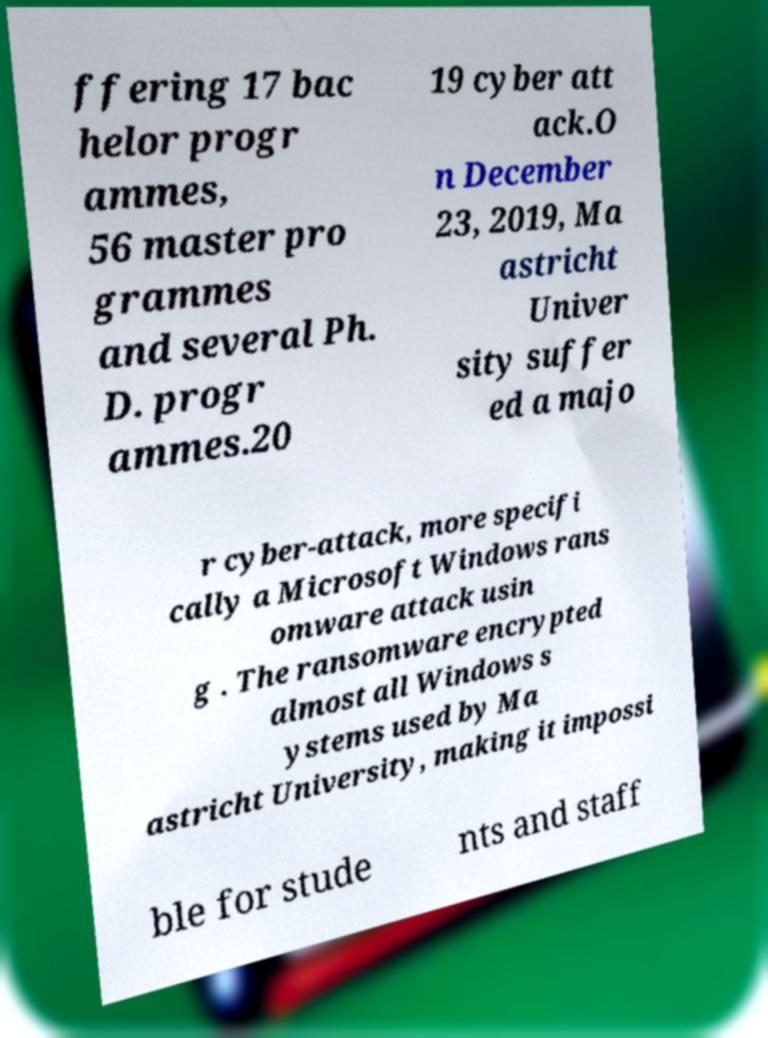Please read and relay the text visible in this image. What does it say? ffering 17 bac helor progr ammes, 56 master pro grammes and several Ph. D. progr ammes.20 19 cyber att ack.O n December 23, 2019, Ma astricht Univer sity suffer ed a majo r cyber-attack, more specifi cally a Microsoft Windows rans omware attack usin g . The ransomware encrypted almost all Windows s ystems used by Ma astricht University, making it impossi ble for stude nts and staff 